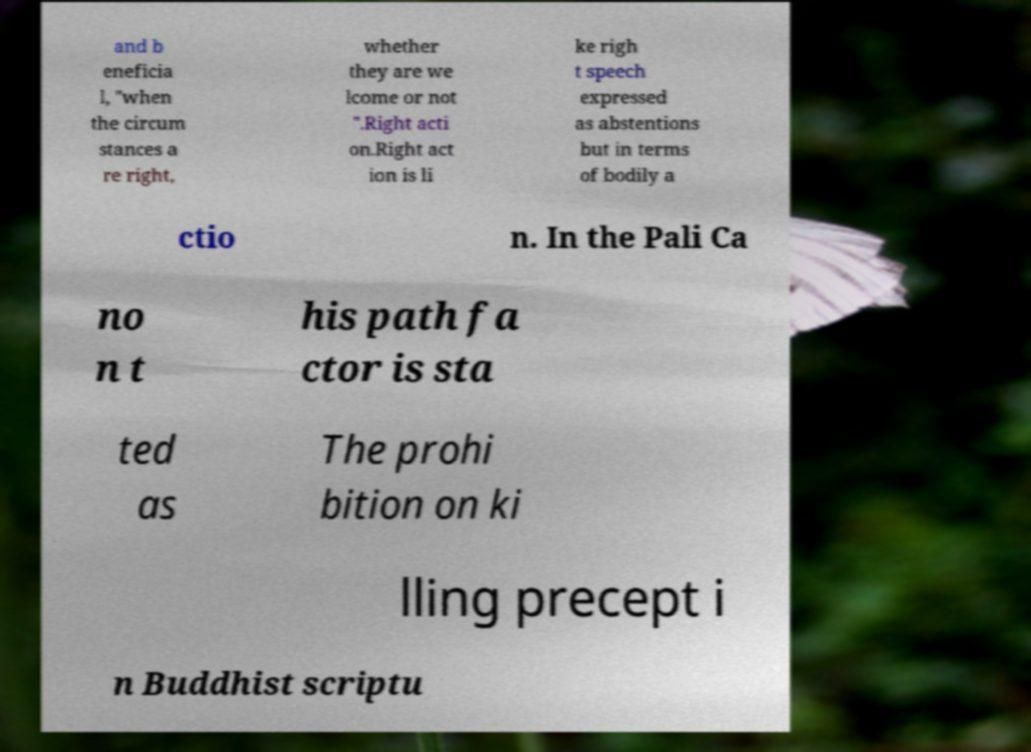Can you accurately transcribe the text from the provided image for me? and b eneficia l, "when the circum stances a re right, whether they are we lcome or not ".Right acti on.Right act ion is li ke righ t speech expressed as abstentions but in terms of bodily a ctio n. In the Pali Ca no n t his path fa ctor is sta ted as The prohi bition on ki lling precept i n Buddhist scriptu 